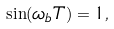<formula> <loc_0><loc_0><loc_500><loc_500>\sin ( \omega _ { b } T ) = 1 ,</formula> 